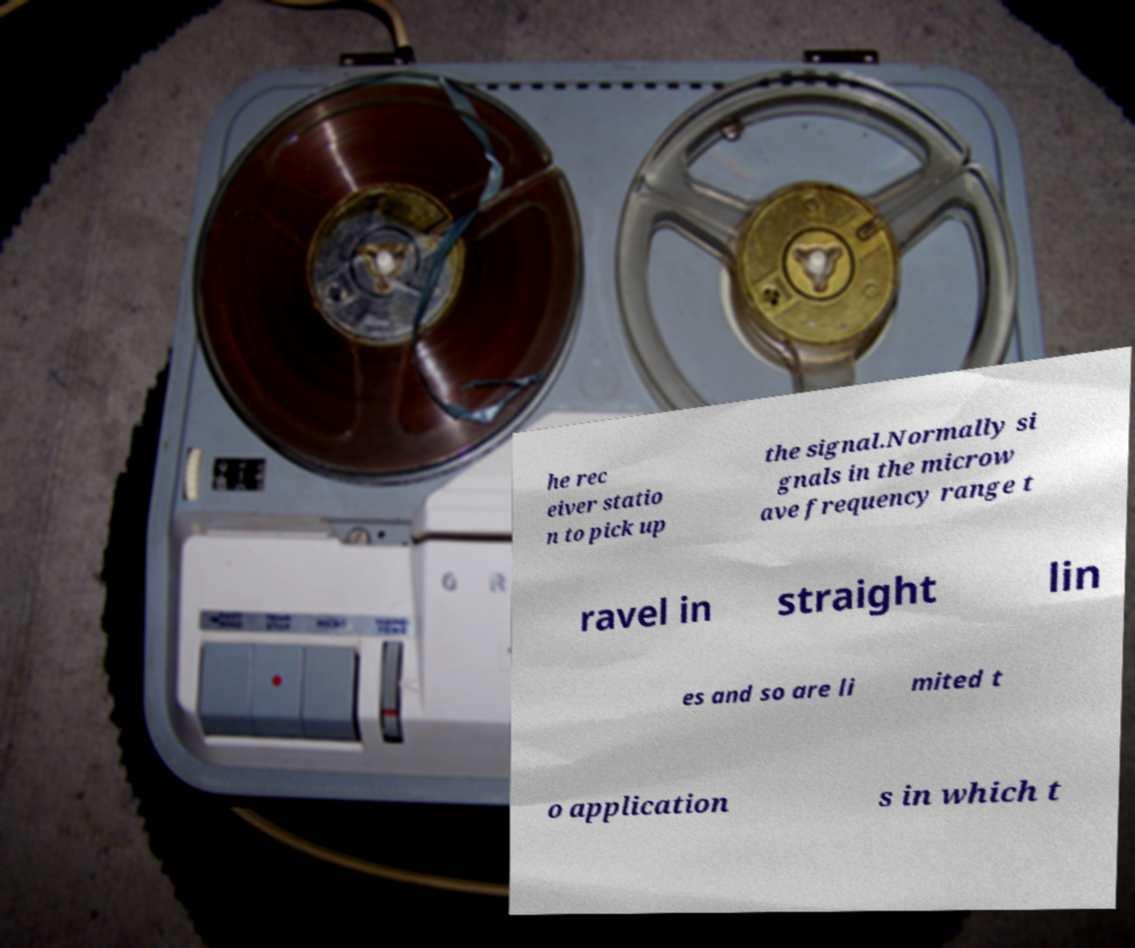Please identify and transcribe the text found in this image. he rec eiver statio n to pick up the signal.Normally si gnals in the microw ave frequency range t ravel in straight lin es and so are li mited t o application s in which t 